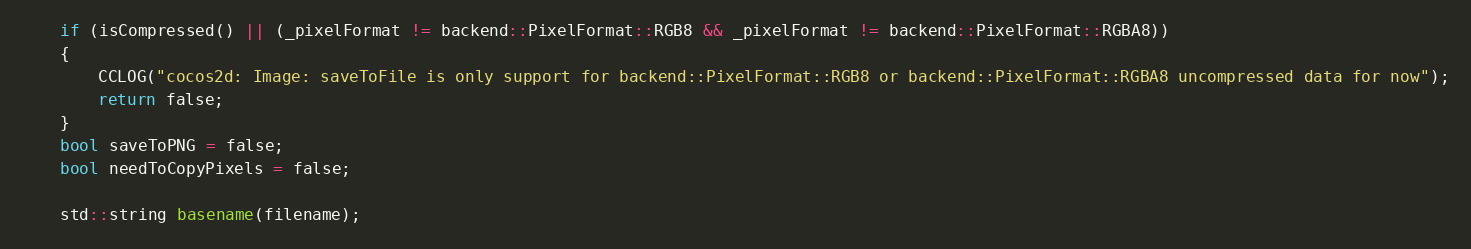<code> <loc_0><loc_0><loc_500><loc_500><_ObjectiveC_>    if (isCompressed() || (_pixelFormat != backend::PixelFormat::RGB8 && _pixelFormat != backend::PixelFormat::RGBA8))
    {
        CCLOG("cocos2d: Image: saveToFile is only support for backend::PixelFormat::RGB8 or backend::PixelFormat::RGBA8 uncompressed data for now");
        return false;
    }
    bool saveToPNG = false;
    bool needToCopyPixels = false;

    std::string basename(filename);</code> 